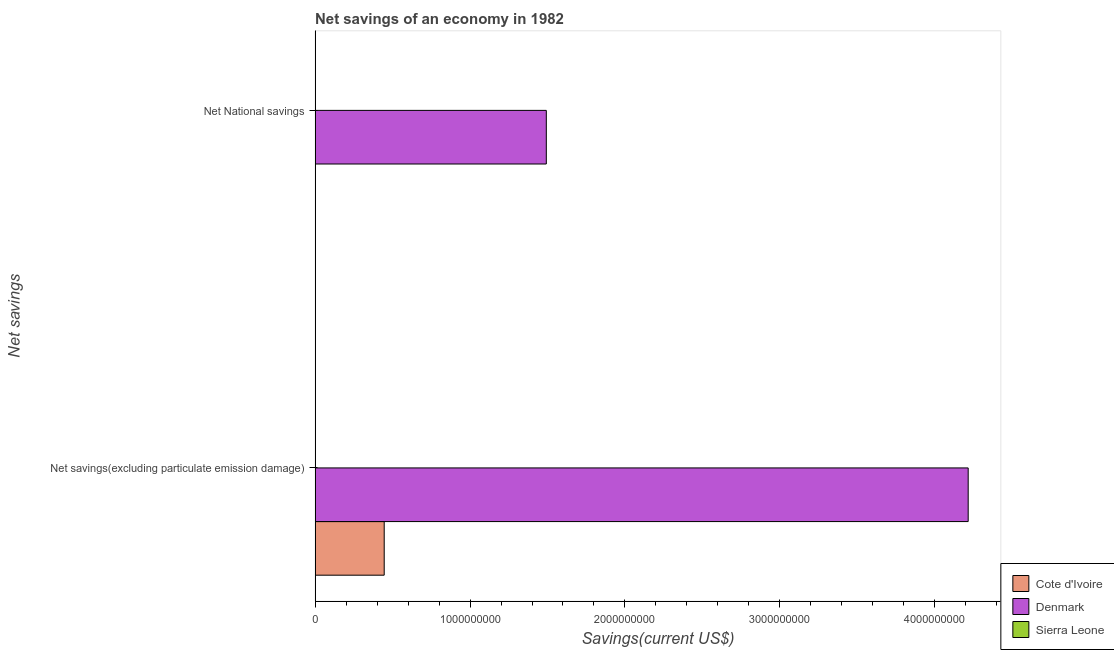How many different coloured bars are there?
Your answer should be compact. 2. Are the number of bars on each tick of the Y-axis equal?
Offer a terse response. No. How many bars are there on the 2nd tick from the bottom?
Offer a terse response. 1. What is the label of the 1st group of bars from the top?
Offer a very short reply. Net National savings. What is the net savings(excluding particulate emission damage) in Sierra Leone?
Make the answer very short. 0. Across all countries, what is the maximum net savings(excluding particulate emission damage)?
Offer a terse response. 4.22e+09. In which country was the net national savings maximum?
Ensure brevity in your answer.  Denmark. What is the total net national savings in the graph?
Make the answer very short. 1.49e+09. What is the difference between the net savings(excluding particulate emission damage) in Cote d'Ivoire and that in Denmark?
Your response must be concise. -3.77e+09. What is the difference between the net national savings in Denmark and the net savings(excluding particulate emission damage) in Sierra Leone?
Provide a short and direct response. 1.49e+09. What is the average net savings(excluding particulate emission damage) per country?
Make the answer very short. 1.55e+09. What is the difference between the net national savings and net savings(excluding particulate emission damage) in Denmark?
Provide a succinct answer. -2.72e+09. In how many countries, is the net savings(excluding particulate emission damage) greater than 400000000 US$?
Offer a very short reply. 2. In how many countries, is the net national savings greater than the average net national savings taken over all countries?
Give a very brief answer. 1. How many countries are there in the graph?
Make the answer very short. 3. Are the values on the major ticks of X-axis written in scientific E-notation?
Offer a very short reply. No. Does the graph contain any zero values?
Make the answer very short. Yes. Does the graph contain grids?
Provide a succinct answer. No. How many legend labels are there?
Ensure brevity in your answer.  3. How are the legend labels stacked?
Give a very brief answer. Vertical. What is the title of the graph?
Provide a succinct answer. Net savings of an economy in 1982. Does "Isle of Man" appear as one of the legend labels in the graph?
Your response must be concise. No. What is the label or title of the X-axis?
Your answer should be compact. Savings(current US$). What is the label or title of the Y-axis?
Your response must be concise. Net savings. What is the Savings(current US$) of Cote d'Ivoire in Net savings(excluding particulate emission damage)?
Your response must be concise. 4.46e+08. What is the Savings(current US$) of Denmark in Net savings(excluding particulate emission damage)?
Give a very brief answer. 4.22e+09. What is the Savings(current US$) of Cote d'Ivoire in Net National savings?
Provide a short and direct response. 0. What is the Savings(current US$) in Denmark in Net National savings?
Provide a succinct answer. 1.49e+09. What is the Savings(current US$) in Sierra Leone in Net National savings?
Keep it short and to the point. 0. Across all Net savings, what is the maximum Savings(current US$) of Cote d'Ivoire?
Offer a very short reply. 4.46e+08. Across all Net savings, what is the maximum Savings(current US$) in Denmark?
Provide a succinct answer. 4.22e+09. Across all Net savings, what is the minimum Savings(current US$) in Denmark?
Ensure brevity in your answer.  1.49e+09. What is the total Savings(current US$) of Cote d'Ivoire in the graph?
Make the answer very short. 4.46e+08. What is the total Savings(current US$) of Denmark in the graph?
Ensure brevity in your answer.  5.71e+09. What is the total Savings(current US$) of Sierra Leone in the graph?
Your answer should be compact. 0. What is the difference between the Savings(current US$) of Denmark in Net savings(excluding particulate emission damage) and that in Net National savings?
Keep it short and to the point. 2.72e+09. What is the difference between the Savings(current US$) of Cote d'Ivoire in Net savings(excluding particulate emission damage) and the Savings(current US$) of Denmark in Net National savings?
Your answer should be compact. -1.05e+09. What is the average Savings(current US$) of Cote d'Ivoire per Net savings?
Provide a short and direct response. 2.23e+08. What is the average Savings(current US$) in Denmark per Net savings?
Offer a terse response. 2.85e+09. What is the difference between the Savings(current US$) of Cote d'Ivoire and Savings(current US$) of Denmark in Net savings(excluding particulate emission damage)?
Your answer should be compact. -3.77e+09. What is the ratio of the Savings(current US$) in Denmark in Net savings(excluding particulate emission damage) to that in Net National savings?
Offer a very short reply. 2.82. What is the difference between the highest and the second highest Savings(current US$) in Denmark?
Provide a short and direct response. 2.72e+09. What is the difference between the highest and the lowest Savings(current US$) in Cote d'Ivoire?
Your response must be concise. 4.46e+08. What is the difference between the highest and the lowest Savings(current US$) in Denmark?
Provide a short and direct response. 2.72e+09. 